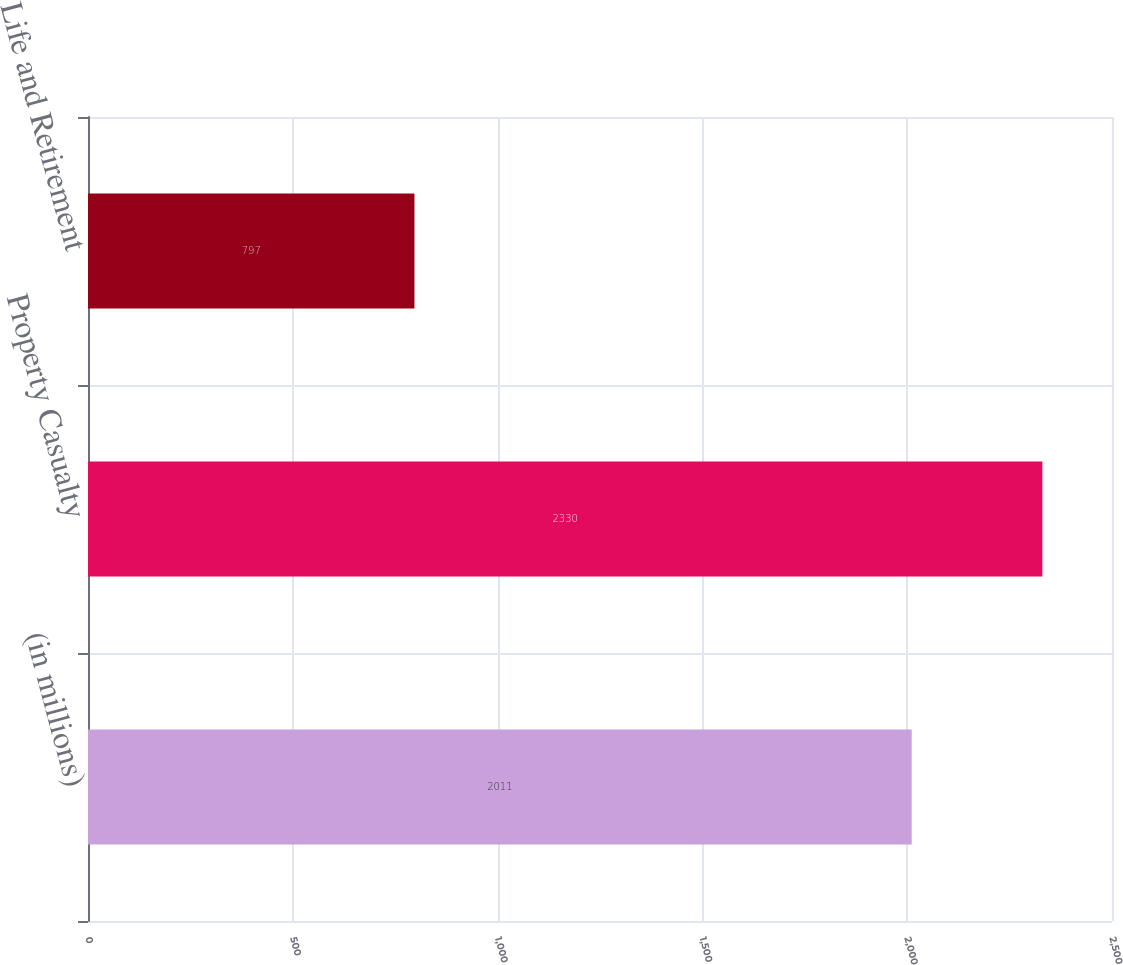<chart> <loc_0><loc_0><loc_500><loc_500><bar_chart><fcel>(in millions)<fcel>Property Casualty<fcel>Life and Retirement<nl><fcel>2011<fcel>2330<fcel>797<nl></chart> 